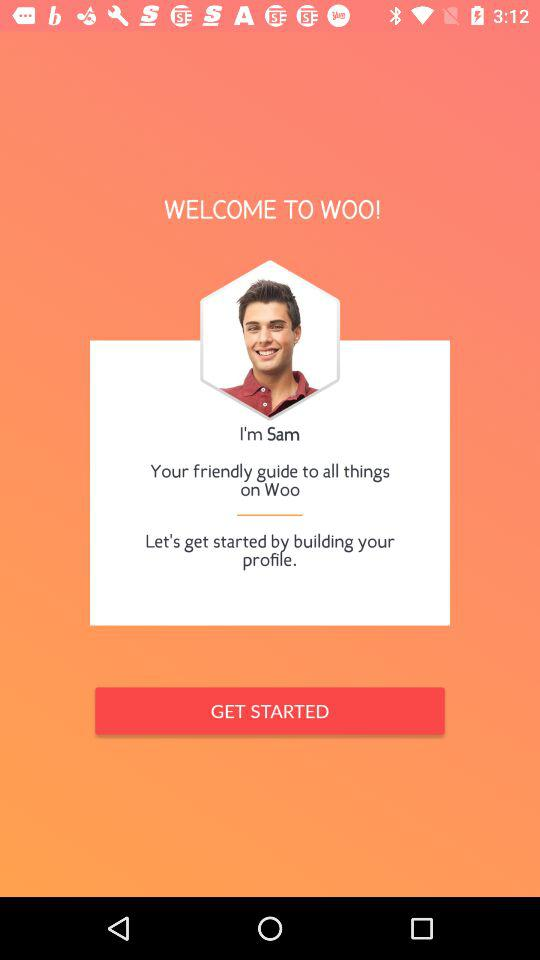What is the name of the user? The name of the user is Sam. 